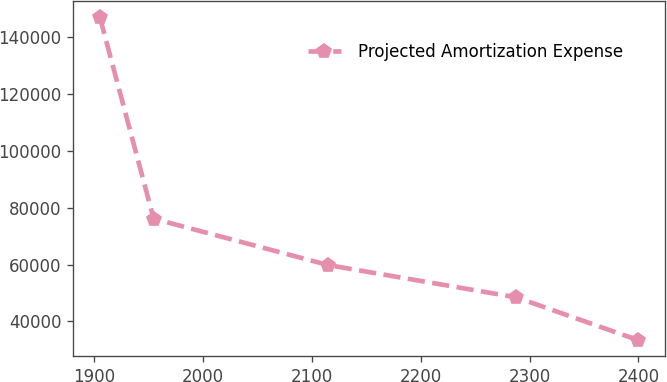Convert chart. <chart><loc_0><loc_0><loc_500><loc_500><line_chart><ecel><fcel>Projected Amortization Expense<nl><fcel>1905.21<fcel>147150<nl><fcel>1954.63<fcel>76171.6<nl><fcel>2115.04<fcel>59833.5<nl><fcel>2287.84<fcel>48463.8<nl><fcel>2399.37<fcel>33453.6<nl></chart> 